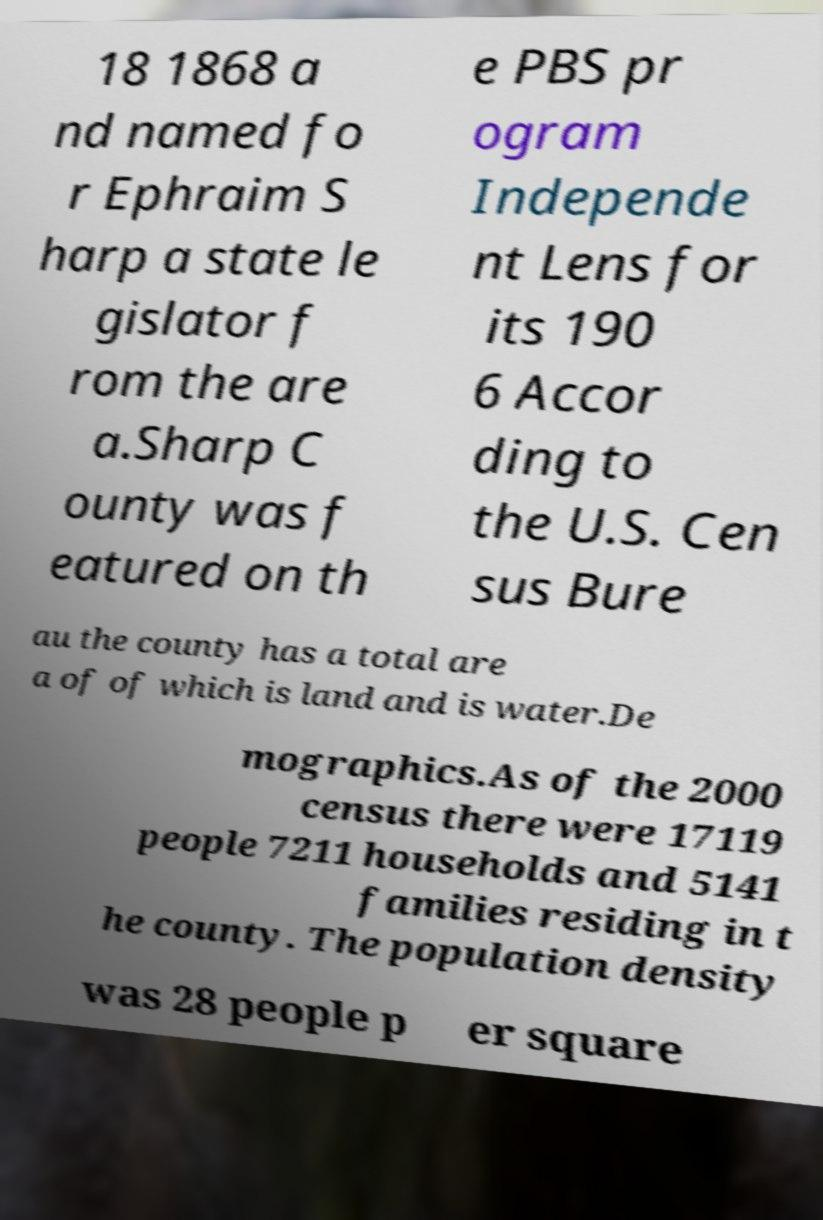For documentation purposes, I need the text within this image transcribed. Could you provide that? 18 1868 a nd named fo r Ephraim S harp a state le gislator f rom the are a.Sharp C ounty was f eatured on th e PBS pr ogram Independe nt Lens for its 190 6 Accor ding to the U.S. Cen sus Bure au the county has a total are a of of which is land and is water.De mographics.As of the 2000 census there were 17119 people 7211 households and 5141 families residing in t he county. The population density was 28 people p er square 